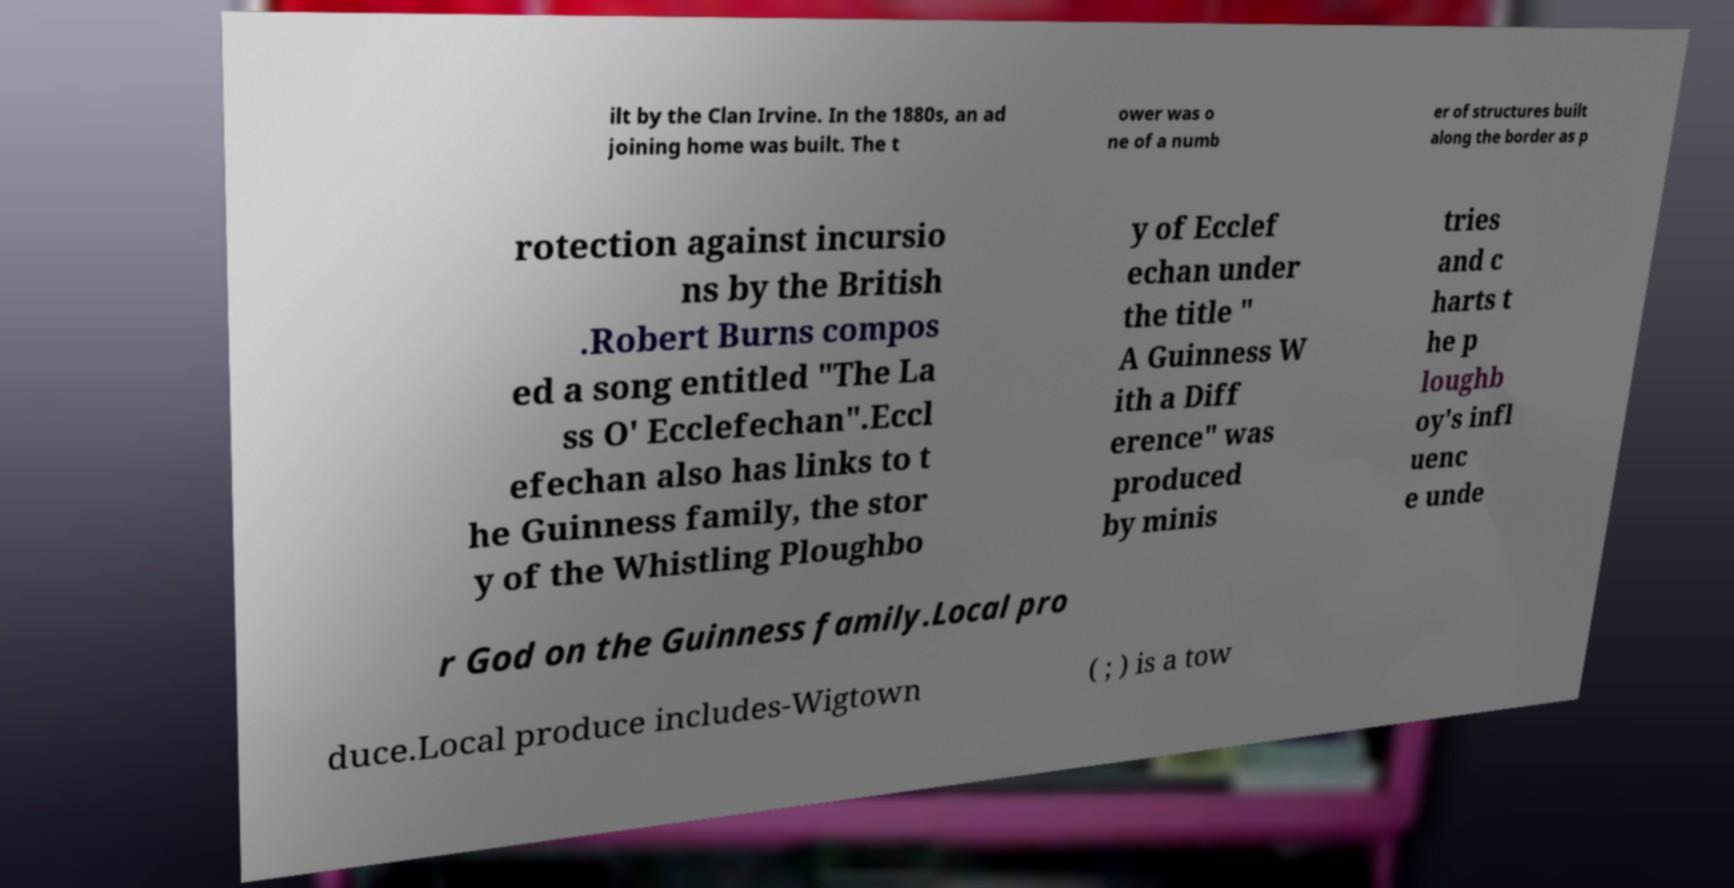Please identify and transcribe the text found in this image. ilt by the Clan Irvine. In the 1880s, an ad joining home was built. The t ower was o ne of a numb er of structures built along the border as p rotection against incursio ns by the British .Robert Burns compos ed a song entitled "The La ss O' Ecclefechan".Eccl efechan also has links to t he Guinness family, the stor y of the Whistling Ploughbo y of Ecclef echan under the title " A Guinness W ith a Diff erence" was produced by minis tries and c harts t he p loughb oy's infl uenc e unde r God on the Guinness family.Local pro duce.Local produce includes-Wigtown ( ; ) is a tow 